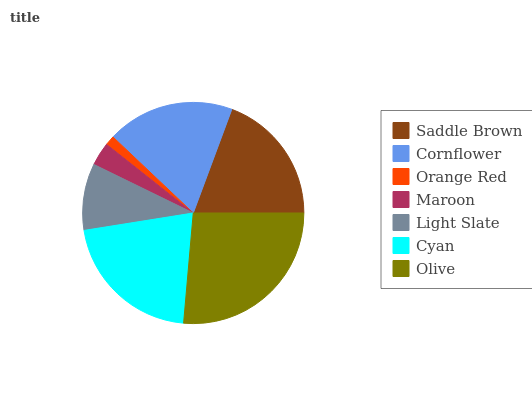Is Orange Red the minimum?
Answer yes or no. Yes. Is Olive the maximum?
Answer yes or no. Yes. Is Cornflower the minimum?
Answer yes or no. No. Is Cornflower the maximum?
Answer yes or no. No. Is Saddle Brown greater than Cornflower?
Answer yes or no. Yes. Is Cornflower less than Saddle Brown?
Answer yes or no. Yes. Is Cornflower greater than Saddle Brown?
Answer yes or no. No. Is Saddle Brown less than Cornflower?
Answer yes or no. No. Is Cornflower the high median?
Answer yes or no. Yes. Is Cornflower the low median?
Answer yes or no. Yes. Is Orange Red the high median?
Answer yes or no. No. Is Light Slate the low median?
Answer yes or no. No. 